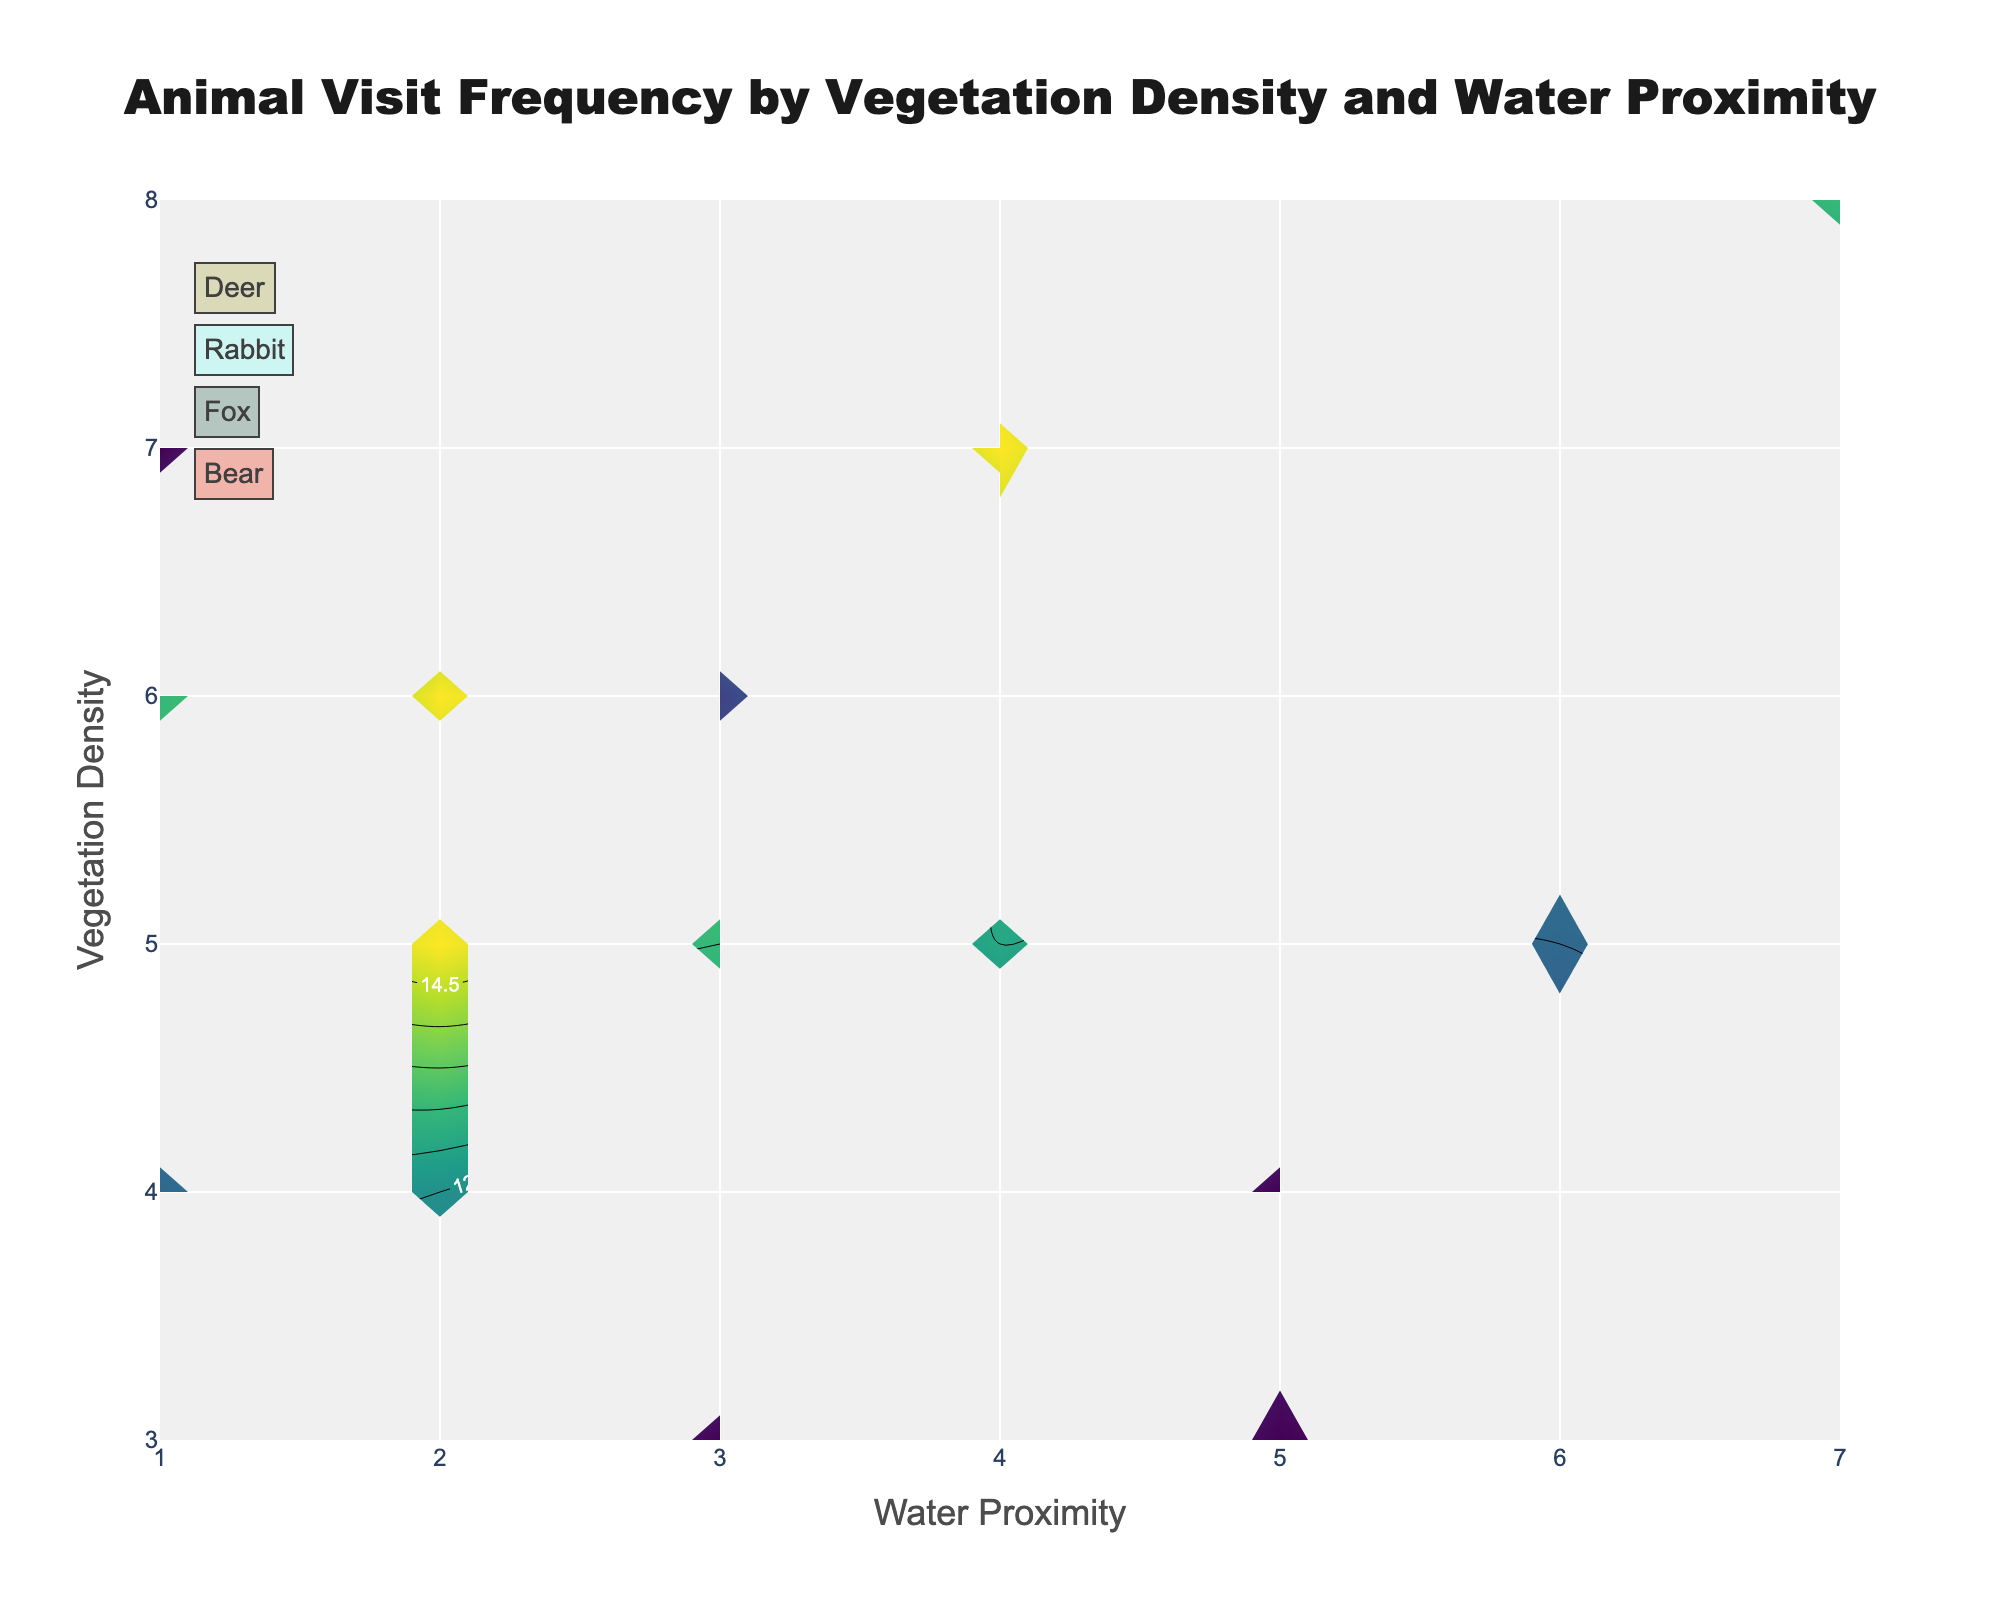What's the title of the plot? The title of the plot is typically found at the top center of the visual representation, and it gives a quick summary of what the plot is about. Here, it reads "Animal Visit Frequency by Vegetation Density and Water Proximity".
Answer: Animal Visit Frequency by Vegetation Density and Water Proximity What do the x-axis and y-axis represent? The x-axis and y-axis labels provide information on what data the axes are representing. Here, the x-axis is labeled "Water Proximity", and the y-axis is labeled "Vegetation Density".
Answer: Water Proximity and Vegetation Density Which species has the highest visit frequency in areas with vegetation density of 5? To find the highest visit frequency for vegetation density of 5, you look at the intersection points for each species at that vegetation density level. Observing the contours, you see that Rabbit has a contour plot with the highest frequency point in this range.
Answer: Rabbit Compare the visit frequencies of Deer and Fox in areas with water proximity of 2 and vegetation density of 6. Which has a higher frequency? Identify the points of interest for each species. For water proximity of 2 and vegetation density of 6, refer to the contour plots of Deer and Fox. Deer has a frequency of 13, and Fox has a frequency of 9.
Answer: Deer What is the general trend of animal visit frequency in relation to vegetation density for Rabbits? To determine the trend, you examine the contour lines for Rabbits across different vegetation density levels. Generally, you see that Rabbit frequency increases from lower to higher vegetation densities.
Answer: Increases In which areas (defined by vegetation density and water proximity) do Bears have the lowest visit frequency? Look for the lowest values on the Bear contour plot by examining the intersection points of given vegetation densities and water proximities. The lowest frequency for Bears is 2, found at vegetation density 3 and water proximity 5.
Answer: Vegetation density 3, water proximity 5 How do visit frequencies for Bears compare in areas with vegetation density 7 and water proximity 4 versus vegetation density 8 and water proximity 7? Check the values for Bears in the contour plot at these coordinates. For vegetation density 7 and water proximity 4, the frequency is 5. For vegetation density 8 and water proximity 7, the frequency is 4.
Answer: Higher at vegetation density 7, water proximity 4 What is the average visit frequency for Foxes across all noted vegetations and water proximities? Add up all frequency values for Foxes (7 + 9 + 8 + 6 = 30) and divide by the number of points (4).
Answer: 7.5 Which animal species shows the most significant variance in visit frequency across different combinations of vegetation density and water proximity? By observing the range and spread of contour lines for each species, assessing which species has the highest difference between its maximum and minimum frequencies. Rabbits have the widest range from 17 to 22, showing significant variance.
Answer: Rabbit Based on the contour plots, which animal species is more influenced by changes in water proximity rather than vegetation density? To determine which species is more influenced, observe the contour lines' sensitivity to changes in water proximity. Deer and Foxes show more variation in frequency with changes in water proximity, indicating stronger influence than vegetation density.
Answer: Deer and Fox 